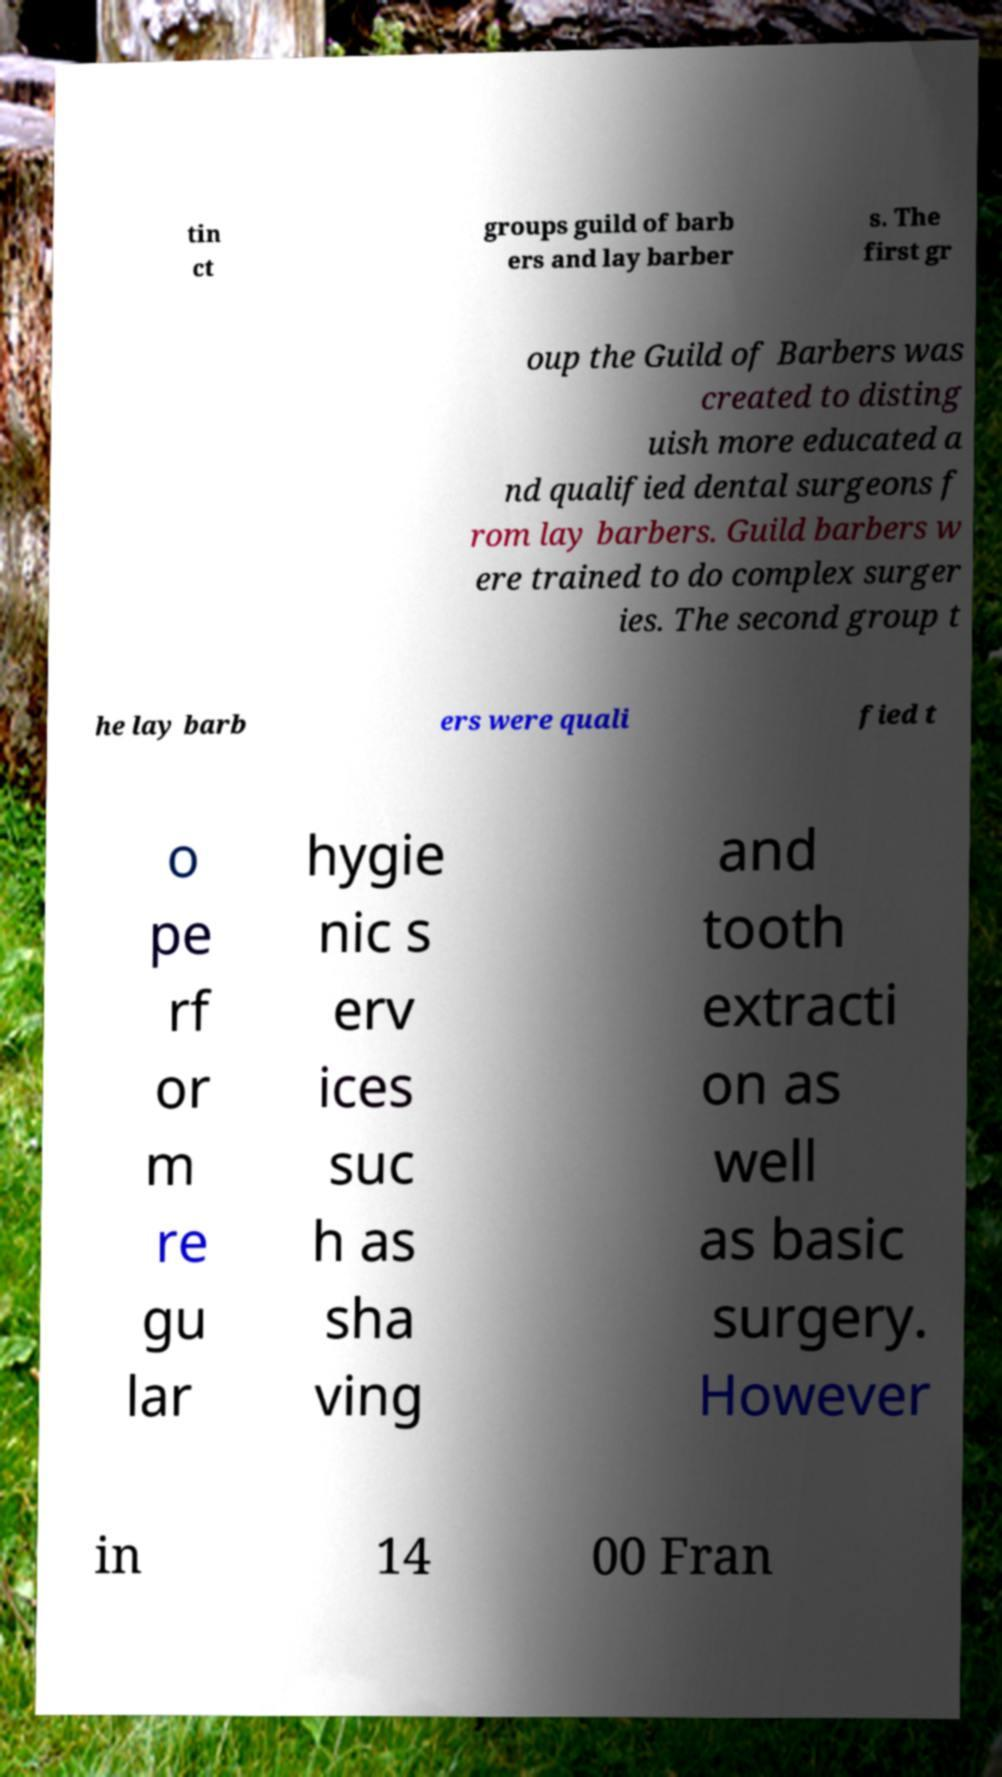Please identify and transcribe the text found in this image. tin ct groups guild of barb ers and lay barber s. The first gr oup the Guild of Barbers was created to disting uish more educated a nd qualified dental surgeons f rom lay barbers. Guild barbers w ere trained to do complex surger ies. The second group t he lay barb ers were quali fied t o pe rf or m re gu lar hygie nic s erv ices suc h as sha ving and tooth extracti on as well as basic surgery. However in 14 00 Fran 